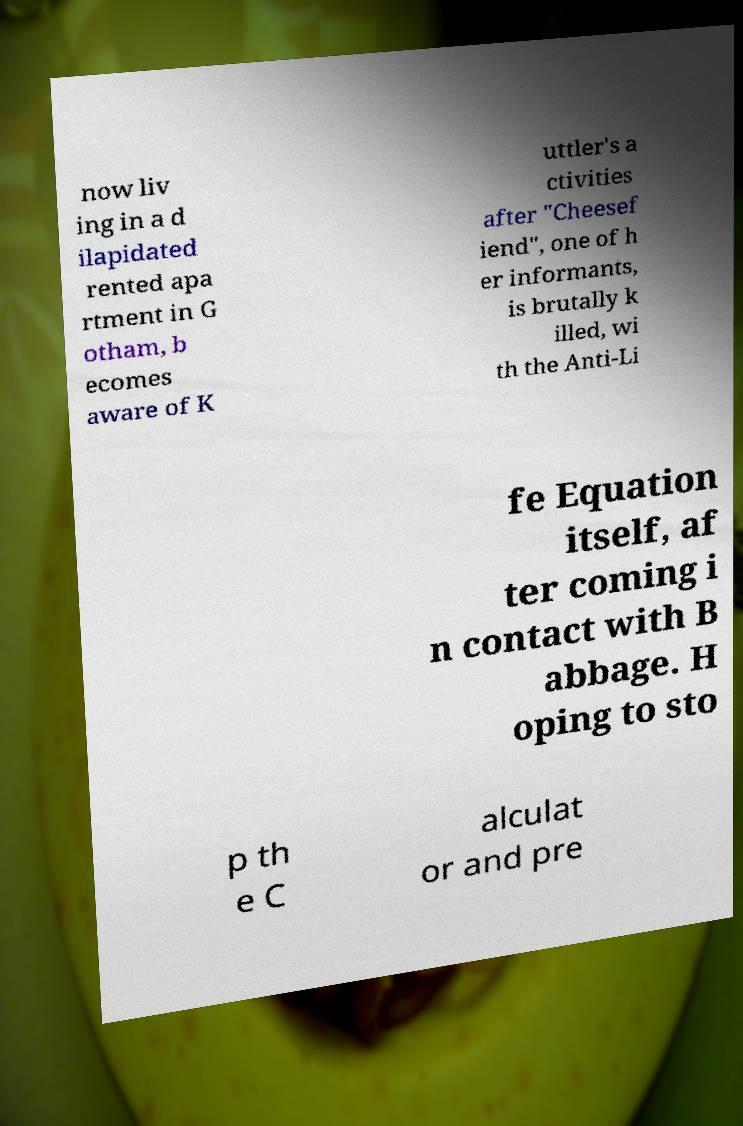I need the written content from this picture converted into text. Can you do that? now liv ing in a d ilapidated rented apa rtment in G otham, b ecomes aware of K uttler's a ctivities after "Cheesef iend", one of h er informants, is brutally k illed, wi th the Anti-Li fe Equation itself, af ter coming i n contact with B abbage. H oping to sto p th e C alculat or and pre 